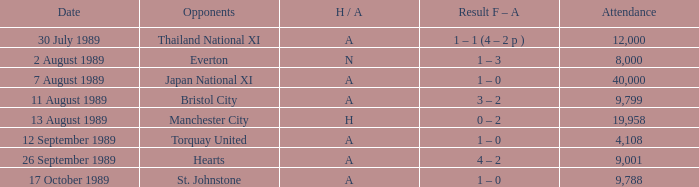When did Manchester United play against Bristol City with an H/A of A? 11 August 1989. 